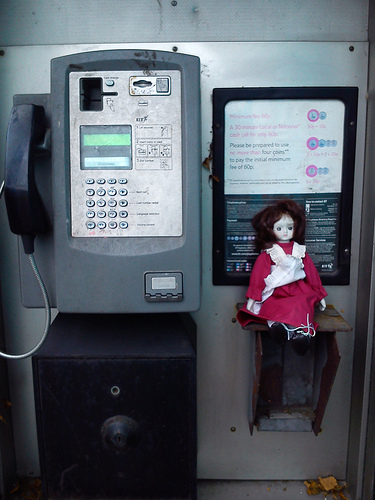<image>
Is the doll to the right of the phone? Yes. From this viewpoint, the doll is positioned to the right side relative to the phone. 